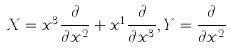Convert formula to latex. <formula><loc_0><loc_0><loc_500><loc_500>X = x ^ { 3 } \frac { \partial } { \partial x ^ { 2 } } + x ^ { 1 } \frac { \partial } { \partial x ^ { 3 } } , Y = \frac { \partial } { \partial x ^ { 2 } }</formula> 